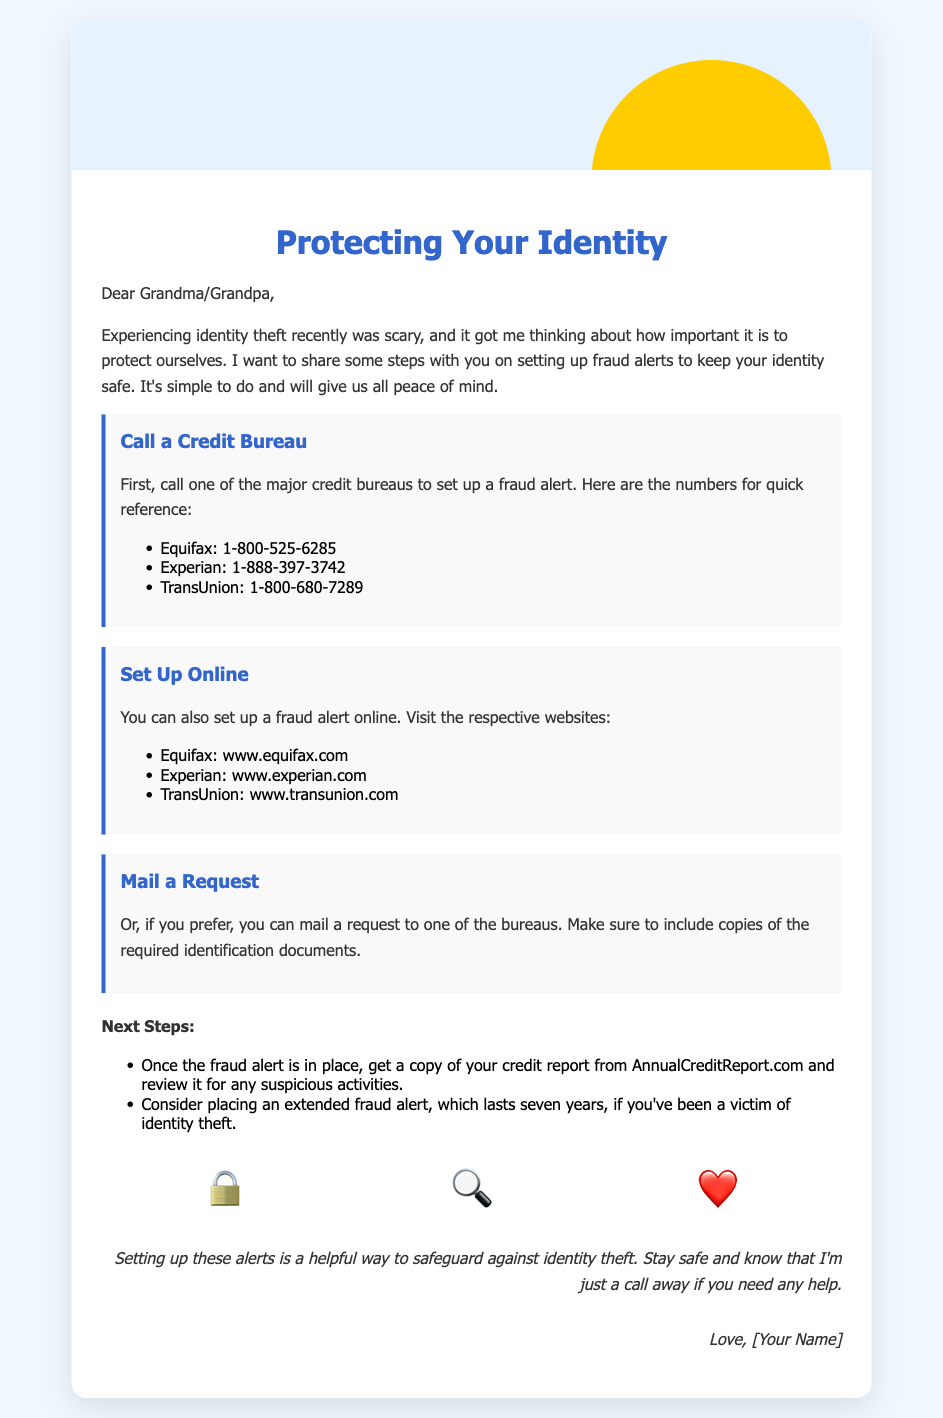What is the purpose of the card? The card aims to provide information on setting up fraud alerts to protect identity.
Answer: Protecting Your Identity Who should be contacted to set up a fraud alert? The card mentions calling one of the major credit bureaus to set up a fraud alert.
Answer: Credit bureaus What are the numbers for Equifax? The document lists the phone number for Equifax as part of setting up a fraud alert.
Answer: 1-800-525-6285 How long does an extended fraud alert last? The card describes the duration of an extended fraud alert for victims of identity theft.
Answer: Seven years What is the first step mentioned to set up a fraud alert? The card indicates the first action to take as calling one of the credit bureaus.
Answer: Call a Credit Bureau Which website is provided for Experian? The card includes a website reference for setting up a fraud alert online.
Answer: www.experian.com 